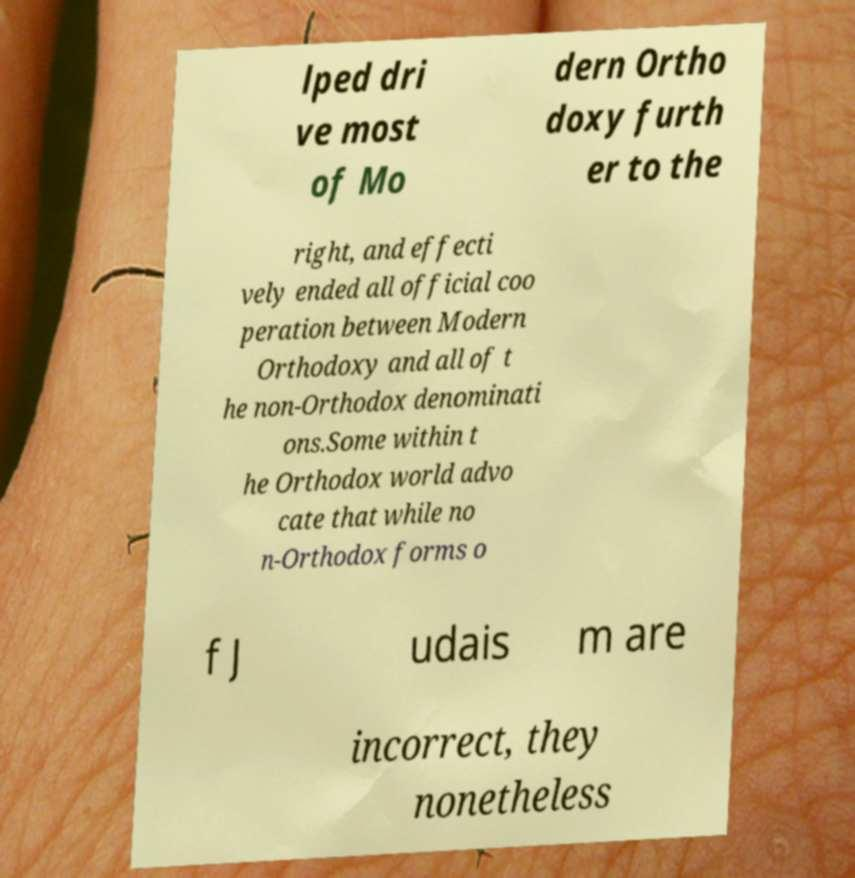Could you assist in decoding the text presented in this image and type it out clearly? lped dri ve most of Mo dern Ortho doxy furth er to the right, and effecti vely ended all official coo peration between Modern Orthodoxy and all of t he non-Orthodox denominati ons.Some within t he Orthodox world advo cate that while no n-Orthodox forms o f J udais m are incorrect, they nonetheless 